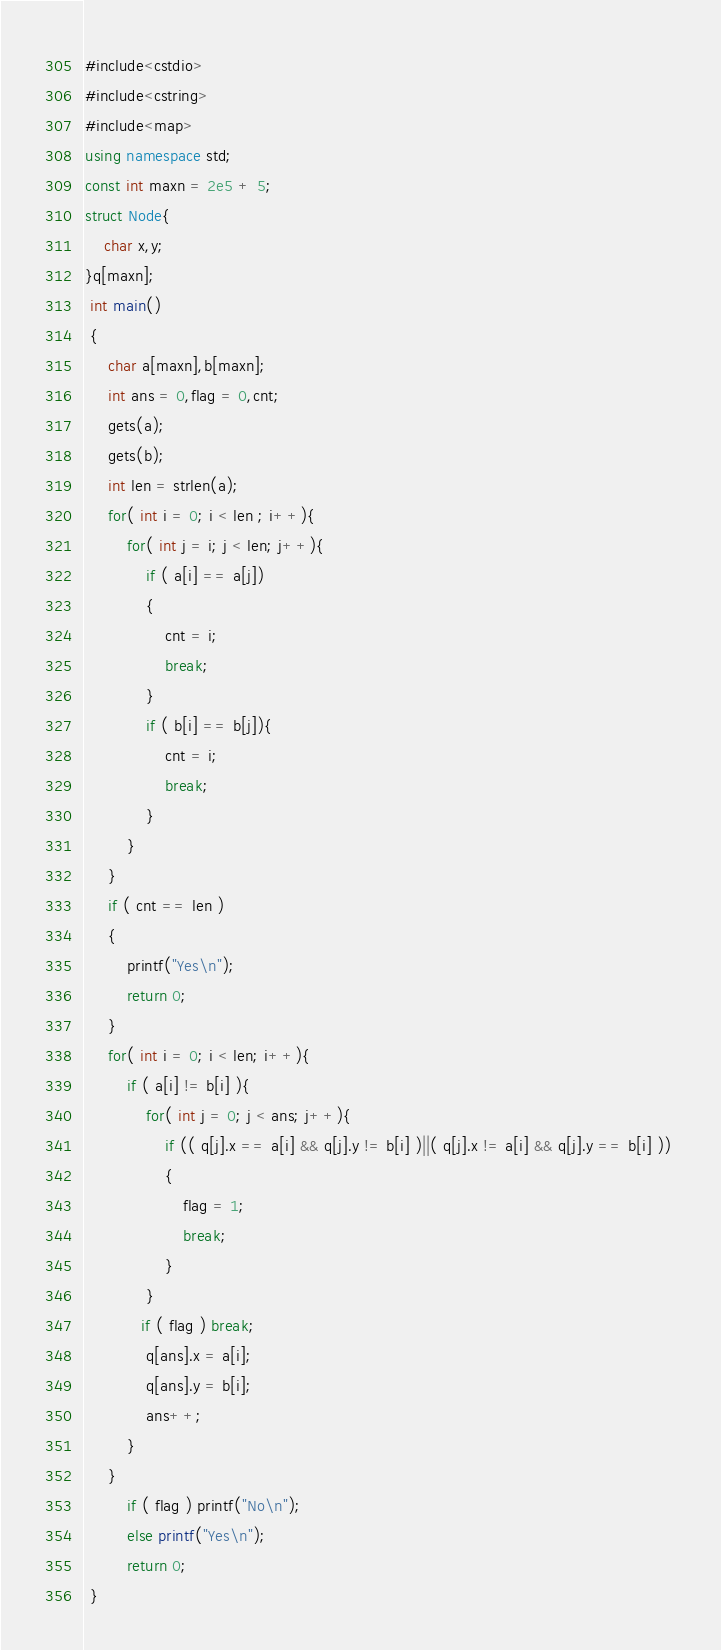<code> <loc_0><loc_0><loc_500><loc_500><_C#_>#include<cstdio>
#include<cstring>
#include<map>
using namespace std;
const int maxn = 2e5 + 5;
struct Node{
	char x,y;
}q[maxn];
 int main()
 {
 	 char a[maxn],b[maxn];
 	 int ans = 0,flag = 0,cnt;
 	 gets(a);
 	 gets(b);
 	 int len = strlen(a);
 	 for( int i = 0; i < len ; i++){
	 	 for( int j = i; j < len; j++){
		 	 if ( a[i] == a[j])
			 {
			 	 cnt = i;
			 	 break;
			 }
		 	 if ( b[i] == b[j]){ 
			 	 cnt = i;
			 	 break;
			 }
		 }
	 }
	 if ( cnt == len ) 
	 {
	 	 printf("Yes\n");
	 	 return 0;
	 }
 	 for( int i = 0; i < len; i++){
	 	 if ( a[i] != b[i] ){
	 	 	 for( int j = 0; j < ans; j++){
			 	 if (( q[j].x == a[i] && q[j].y != b[i] )||( q[j].x != a[i] && q[j].y == b[i] )) 
				 {
				 	 flag = 1;
				 	 break;
				 }
			 }
			if ( flag ) break;
	 	 	 q[ans].x = a[i];
	 	 	 q[ans].y = b[i];
	 	 	 ans++;
		 }
	 }
		 if ( flag ) printf("No\n");
		 else printf("Yes\n");
		 return 0;
 }</code> 